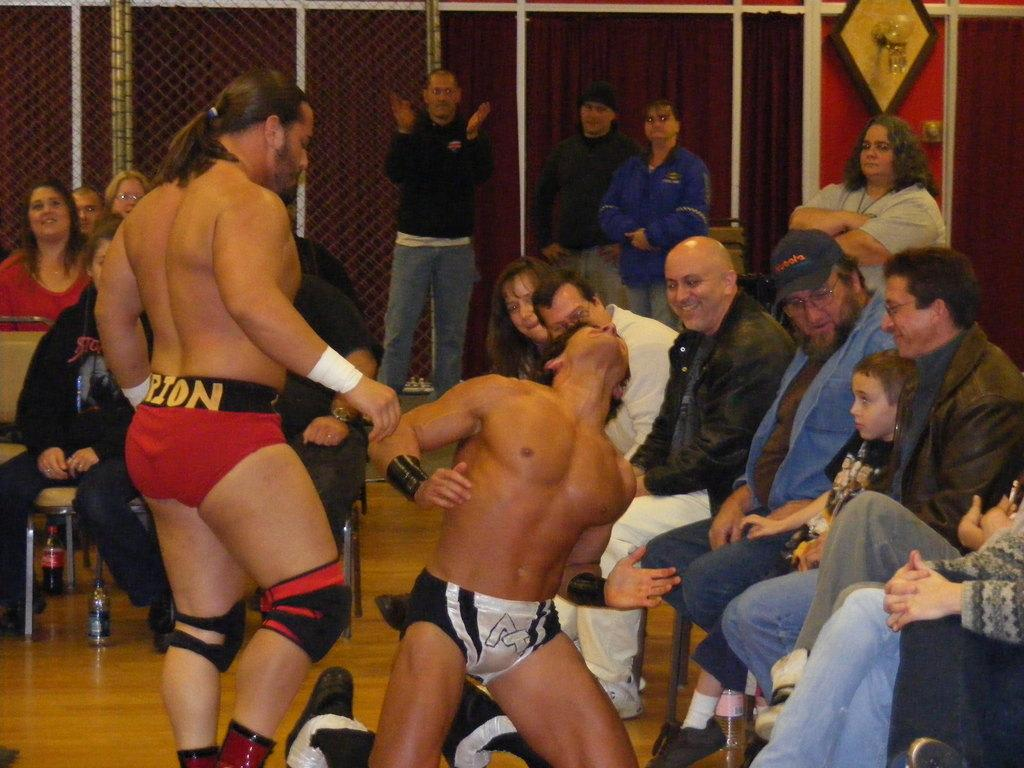What is happening in the image involving two people? There are two wrestlers in the image. How many people are present around the wrestlers? There are many people around the wrestlers. What can be seen in the background of the image? There is a mesh in the background of the image. What is located beside the mesh? There is a curtain beside the mesh. What type of fan is visible in the image? There is no fan present in the image. How many feet can be seen in the image? The image does not show any feet; it focuses on the wrestlers and the people around them. 